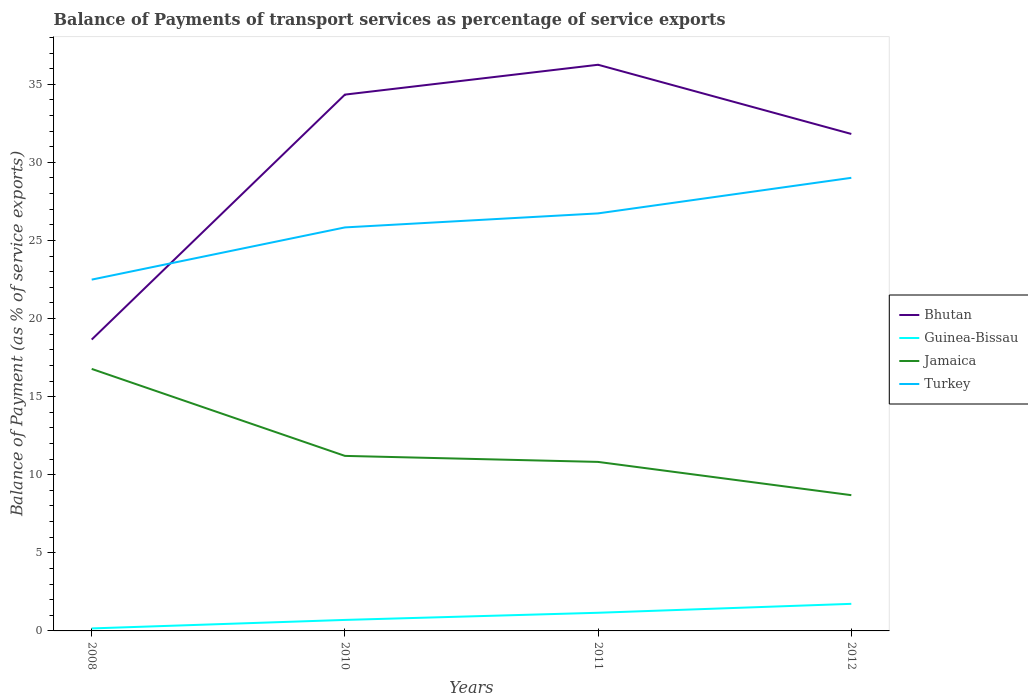Across all years, what is the maximum balance of payments of transport services in Jamaica?
Your answer should be compact. 8.69. What is the total balance of payments of transport services in Bhutan in the graph?
Your response must be concise. -15.68. What is the difference between the highest and the second highest balance of payments of transport services in Guinea-Bissau?
Keep it short and to the point. 1.57. What is the difference between the highest and the lowest balance of payments of transport services in Turkey?
Your answer should be very brief. 2. Is the balance of payments of transport services in Jamaica strictly greater than the balance of payments of transport services in Turkey over the years?
Offer a terse response. Yes. How many lines are there?
Make the answer very short. 4. Are the values on the major ticks of Y-axis written in scientific E-notation?
Offer a terse response. No. Does the graph contain any zero values?
Keep it short and to the point. No. Does the graph contain grids?
Give a very brief answer. No. What is the title of the graph?
Your answer should be compact. Balance of Payments of transport services as percentage of service exports. What is the label or title of the X-axis?
Give a very brief answer. Years. What is the label or title of the Y-axis?
Ensure brevity in your answer.  Balance of Payment (as % of service exports). What is the Balance of Payment (as % of service exports) of Bhutan in 2008?
Offer a very short reply. 18.65. What is the Balance of Payment (as % of service exports) in Guinea-Bissau in 2008?
Offer a very short reply. 0.16. What is the Balance of Payment (as % of service exports) of Jamaica in 2008?
Give a very brief answer. 16.78. What is the Balance of Payment (as % of service exports) in Turkey in 2008?
Provide a succinct answer. 22.49. What is the Balance of Payment (as % of service exports) of Bhutan in 2010?
Provide a succinct answer. 34.34. What is the Balance of Payment (as % of service exports) of Guinea-Bissau in 2010?
Keep it short and to the point. 0.7. What is the Balance of Payment (as % of service exports) of Jamaica in 2010?
Offer a terse response. 11.21. What is the Balance of Payment (as % of service exports) of Turkey in 2010?
Give a very brief answer. 25.84. What is the Balance of Payment (as % of service exports) in Bhutan in 2011?
Ensure brevity in your answer.  36.25. What is the Balance of Payment (as % of service exports) in Guinea-Bissau in 2011?
Provide a short and direct response. 1.16. What is the Balance of Payment (as % of service exports) in Jamaica in 2011?
Make the answer very short. 10.82. What is the Balance of Payment (as % of service exports) in Turkey in 2011?
Ensure brevity in your answer.  26.73. What is the Balance of Payment (as % of service exports) of Bhutan in 2012?
Offer a terse response. 31.82. What is the Balance of Payment (as % of service exports) in Guinea-Bissau in 2012?
Ensure brevity in your answer.  1.73. What is the Balance of Payment (as % of service exports) in Jamaica in 2012?
Ensure brevity in your answer.  8.69. What is the Balance of Payment (as % of service exports) in Turkey in 2012?
Your answer should be compact. 29.01. Across all years, what is the maximum Balance of Payment (as % of service exports) in Bhutan?
Give a very brief answer. 36.25. Across all years, what is the maximum Balance of Payment (as % of service exports) in Guinea-Bissau?
Offer a very short reply. 1.73. Across all years, what is the maximum Balance of Payment (as % of service exports) of Jamaica?
Offer a very short reply. 16.78. Across all years, what is the maximum Balance of Payment (as % of service exports) of Turkey?
Your answer should be very brief. 29.01. Across all years, what is the minimum Balance of Payment (as % of service exports) of Bhutan?
Your answer should be very brief. 18.65. Across all years, what is the minimum Balance of Payment (as % of service exports) of Guinea-Bissau?
Your response must be concise. 0.16. Across all years, what is the minimum Balance of Payment (as % of service exports) in Jamaica?
Offer a terse response. 8.69. Across all years, what is the minimum Balance of Payment (as % of service exports) of Turkey?
Your answer should be compact. 22.49. What is the total Balance of Payment (as % of service exports) of Bhutan in the graph?
Your answer should be very brief. 121.06. What is the total Balance of Payment (as % of service exports) in Guinea-Bissau in the graph?
Keep it short and to the point. 3.76. What is the total Balance of Payment (as % of service exports) in Jamaica in the graph?
Give a very brief answer. 47.5. What is the total Balance of Payment (as % of service exports) in Turkey in the graph?
Provide a succinct answer. 104.07. What is the difference between the Balance of Payment (as % of service exports) of Bhutan in 2008 and that in 2010?
Your answer should be compact. -15.68. What is the difference between the Balance of Payment (as % of service exports) in Guinea-Bissau in 2008 and that in 2010?
Offer a terse response. -0.54. What is the difference between the Balance of Payment (as % of service exports) in Jamaica in 2008 and that in 2010?
Provide a succinct answer. 5.57. What is the difference between the Balance of Payment (as % of service exports) of Turkey in 2008 and that in 2010?
Give a very brief answer. -3.34. What is the difference between the Balance of Payment (as % of service exports) of Bhutan in 2008 and that in 2011?
Your answer should be compact. -17.6. What is the difference between the Balance of Payment (as % of service exports) of Guinea-Bissau in 2008 and that in 2011?
Provide a succinct answer. -1. What is the difference between the Balance of Payment (as % of service exports) of Jamaica in 2008 and that in 2011?
Your answer should be very brief. 5.96. What is the difference between the Balance of Payment (as % of service exports) of Turkey in 2008 and that in 2011?
Offer a terse response. -4.24. What is the difference between the Balance of Payment (as % of service exports) in Bhutan in 2008 and that in 2012?
Your answer should be compact. -13.17. What is the difference between the Balance of Payment (as % of service exports) in Guinea-Bissau in 2008 and that in 2012?
Ensure brevity in your answer.  -1.57. What is the difference between the Balance of Payment (as % of service exports) of Jamaica in 2008 and that in 2012?
Give a very brief answer. 8.08. What is the difference between the Balance of Payment (as % of service exports) in Turkey in 2008 and that in 2012?
Keep it short and to the point. -6.52. What is the difference between the Balance of Payment (as % of service exports) of Bhutan in 2010 and that in 2011?
Keep it short and to the point. -1.91. What is the difference between the Balance of Payment (as % of service exports) of Guinea-Bissau in 2010 and that in 2011?
Offer a terse response. -0.46. What is the difference between the Balance of Payment (as % of service exports) in Jamaica in 2010 and that in 2011?
Offer a terse response. 0.39. What is the difference between the Balance of Payment (as % of service exports) in Turkey in 2010 and that in 2011?
Your response must be concise. -0.9. What is the difference between the Balance of Payment (as % of service exports) in Bhutan in 2010 and that in 2012?
Make the answer very short. 2.52. What is the difference between the Balance of Payment (as % of service exports) in Guinea-Bissau in 2010 and that in 2012?
Keep it short and to the point. -1.03. What is the difference between the Balance of Payment (as % of service exports) in Jamaica in 2010 and that in 2012?
Provide a succinct answer. 2.52. What is the difference between the Balance of Payment (as % of service exports) of Turkey in 2010 and that in 2012?
Ensure brevity in your answer.  -3.18. What is the difference between the Balance of Payment (as % of service exports) of Bhutan in 2011 and that in 2012?
Provide a short and direct response. 4.43. What is the difference between the Balance of Payment (as % of service exports) of Guinea-Bissau in 2011 and that in 2012?
Provide a short and direct response. -0.57. What is the difference between the Balance of Payment (as % of service exports) of Jamaica in 2011 and that in 2012?
Offer a very short reply. 2.13. What is the difference between the Balance of Payment (as % of service exports) in Turkey in 2011 and that in 2012?
Ensure brevity in your answer.  -2.28. What is the difference between the Balance of Payment (as % of service exports) of Bhutan in 2008 and the Balance of Payment (as % of service exports) of Guinea-Bissau in 2010?
Your answer should be compact. 17.95. What is the difference between the Balance of Payment (as % of service exports) of Bhutan in 2008 and the Balance of Payment (as % of service exports) of Jamaica in 2010?
Provide a short and direct response. 7.45. What is the difference between the Balance of Payment (as % of service exports) of Bhutan in 2008 and the Balance of Payment (as % of service exports) of Turkey in 2010?
Provide a short and direct response. -7.18. What is the difference between the Balance of Payment (as % of service exports) in Guinea-Bissau in 2008 and the Balance of Payment (as % of service exports) in Jamaica in 2010?
Give a very brief answer. -11.05. What is the difference between the Balance of Payment (as % of service exports) in Guinea-Bissau in 2008 and the Balance of Payment (as % of service exports) in Turkey in 2010?
Provide a succinct answer. -25.68. What is the difference between the Balance of Payment (as % of service exports) of Jamaica in 2008 and the Balance of Payment (as % of service exports) of Turkey in 2010?
Your response must be concise. -9.06. What is the difference between the Balance of Payment (as % of service exports) of Bhutan in 2008 and the Balance of Payment (as % of service exports) of Guinea-Bissau in 2011?
Your response must be concise. 17.49. What is the difference between the Balance of Payment (as % of service exports) of Bhutan in 2008 and the Balance of Payment (as % of service exports) of Jamaica in 2011?
Keep it short and to the point. 7.83. What is the difference between the Balance of Payment (as % of service exports) of Bhutan in 2008 and the Balance of Payment (as % of service exports) of Turkey in 2011?
Offer a terse response. -8.08. What is the difference between the Balance of Payment (as % of service exports) in Guinea-Bissau in 2008 and the Balance of Payment (as % of service exports) in Jamaica in 2011?
Your answer should be very brief. -10.66. What is the difference between the Balance of Payment (as % of service exports) of Guinea-Bissau in 2008 and the Balance of Payment (as % of service exports) of Turkey in 2011?
Make the answer very short. -26.57. What is the difference between the Balance of Payment (as % of service exports) of Jamaica in 2008 and the Balance of Payment (as % of service exports) of Turkey in 2011?
Offer a terse response. -9.96. What is the difference between the Balance of Payment (as % of service exports) of Bhutan in 2008 and the Balance of Payment (as % of service exports) of Guinea-Bissau in 2012?
Your response must be concise. 16.92. What is the difference between the Balance of Payment (as % of service exports) in Bhutan in 2008 and the Balance of Payment (as % of service exports) in Jamaica in 2012?
Your response must be concise. 9.96. What is the difference between the Balance of Payment (as % of service exports) in Bhutan in 2008 and the Balance of Payment (as % of service exports) in Turkey in 2012?
Your answer should be very brief. -10.36. What is the difference between the Balance of Payment (as % of service exports) in Guinea-Bissau in 2008 and the Balance of Payment (as % of service exports) in Jamaica in 2012?
Your answer should be compact. -8.53. What is the difference between the Balance of Payment (as % of service exports) of Guinea-Bissau in 2008 and the Balance of Payment (as % of service exports) of Turkey in 2012?
Offer a terse response. -28.85. What is the difference between the Balance of Payment (as % of service exports) in Jamaica in 2008 and the Balance of Payment (as % of service exports) in Turkey in 2012?
Give a very brief answer. -12.23. What is the difference between the Balance of Payment (as % of service exports) of Bhutan in 2010 and the Balance of Payment (as % of service exports) of Guinea-Bissau in 2011?
Provide a succinct answer. 33.18. What is the difference between the Balance of Payment (as % of service exports) in Bhutan in 2010 and the Balance of Payment (as % of service exports) in Jamaica in 2011?
Make the answer very short. 23.52. What is the difference between the Balance of Payment (as % of service exports) of Bhutan in 2010 and the Balance of Payment (as % of service exports) of Turkey in 2011?
Offer a very short reply. 7.6. What is the difference between the Balance of Payment (as % of service exports) in Guinea-Bissau in 2010 and the Balance of Payment (as % of service exports) in Jamaica in 2011?
Provide a short and direct response. -10.12. What is the difference between the Balance of Payment (as % of service exports) in Guinea-Bissau in 2010 and the Balance of Payment (as % of service exports) in Turkey in 2011?
Keep it short and to the point. -26.03. What is the difference between the Balance of Payment (as % of service exports) in Jamaica in 2010 and the Balance of Payment (as % of service exports) in Turkey in 2011?
Your answer should be very brief. -15.53. What is the difference between the Balance of Payment (as % of service exports) of Bhutan in 2010 and the Balance of Payment (as % of service exports) of Guinea-Bissau in 2012?
Offer a terse response. 32.6. What is the difference between the Balance of Payment (as % of service exports) of Bhutan in 2010 and the Balance of Payment (as % of service exports) of Jamaica in 2012?
Your answer should be compact. 25.65. What is the difference between the Balance of Payment (as % of service exports) in Bhutan in 2010 and the Balance of Payment (as % of service exports) in Turkey in 2012?
Your answer should be compact. 5.33. What is the difference between the Balance of Payment (as % of service exports) of Guinea-Bissau in 2010 and the Balance of Payment (as % of service exports) of Jamaica in 2012?
Offer a terse response. -7.99. What is the difference between the Balance of Payment (as % of service exports) in Guinea-Bissau in 2010 and the Balance of Payment (as % of service exports) in Turkey in 2012?
Make the answer very short. -28.31. What is the difference between the Balance of Payment (as % of service exports) of Jamaica in 2010 and the Balance of Payment (as % of service exports) of Turkey in 2012?
Keep it short and to the point. -17.8. What is the difference between the Balance of Payment (as % of service exports) in Bhutan in 2011 and the Balance of Payment (as % of service exports) in Guinea-Bissau in 2012?
Make the answer very short. 34.52. What is the difference between the Balance of Payment (as % of service exports) in Bhutan in 2011 and the Balance of Payment (as % of service exports) in Jamaica in 2012?
Keep it short and to the point. 27.56. What is the difference between the Balance of Payment (as % of service exports) of Bhutan in 2011 and the Balance of Payment (as % of service exports) of Turkey in 2012?
Ensure brevity in your answer.  7.24. What is the difference between the Balance of Payment (as % of service exports) of Guinea-Bissau in 2011 and the Balance of Payment (as % of service exports) of Jamaica in 2012?
Provide a short and direct response. -7.53. What is the difference between the Balance of Payment (as % of service exports) of Guinea-Bissau in 2011 and the Balance of Payment (as % of service exports) of Turkey in 2012?
Provide a short and direct response. -27.85. What is the difference between the Balance of Payment (as % of service exports) in Jamaica in 2011 and the Balance of Payment (as % of service exports) in Turkey in 2012?
Offer a very short reply. -18.19. What is the average Balance of Payment (as % of service exports) in Bhutan per year?
Your response must be concise. 30.27. What is the average Balance of Payment (as % of service exports) in Guinea-Bissau per year?
Your answer should be compact. 0.94. What is the average Balance of Payment (as % of service exports) of Jamaica per year?
Your answer should be compact. 11.87. What is the average Balance of Payment (as % of service exports) of Turkey per year?
Ensure brevity in your answer.  26.02. In the year 2008, what is the difference between the Balance of Payment (as % of service exports) in Bhutan and Balance of Payment (as % of service exports) in Guinea-Bissau?
Your response must be concise. 18.49. In the year 2008, what is the difference between the Balance of Payment (as % of service exports) of Bhutan and Balance of Payment (as % of service exports) of Jamaica?
Your answer should be compact. 1.88. In the year 2008, what is the difference between the Balance of Payment (as % of service exports) of Bhutan and Balance of Payment (as % of service exports) of Turkey?
Your response must be concise. -3.84. In the year 2008, what is the difference between the Balance of Payment (as % of service exports) in Guinea-Bissau and Balance of Payment (as % of service exports) in Jamaica?
Provide a succinct answer. -16.62. In the year 2008, what is the difference between the Balance of Payment (as % of service exports) in Guinea-Bissau and Balance of Payment (as % of service exports) in Turkey?
Offer a very short reply. -22.33. In the year 2008, what is the difference between the Balance of Payment (as % of service exports) in Jamaica and Balance of Payment (as % of service exports) in Turkey?
Offer a terse response. -5.72. In the year 2010, what is the difference between the Balance of Payment (as % of service exports) of Bhutan and Balance of Payment (as % of service exports) of Guinea-Bissau?
Make the answer very short. 33.63. In the year 2010, what is the difference between the Balance of Payment (as % of service exports) of Bhutan and Balance of Payment (as % of service exports) of Jamaica?
Provide a succinct answer. 23.13. In the year 2010, what is the difference between the Balance of Payment (as % of service exports) in Bhutan and Balance of Payment (as % of service exports) in Turkey?
Provide a short and direct response. 8.5. In the year 2010, what is the difference between the Balance of Payment (as % of service exports) of Guinea-Bissau and Balance of Payment (as % of service exports) of Jamaica?
Your answer should be very brief. -10.5. In the year 2010, what is the difference between the Balance of Payment (as % of service exports) in Guinea-Bissau and Balance of Payment (as % of service exports) in Turkey?
Provide a succinct answer. -25.13. In the year 2010, what is the difference between the Balance of Payment (as % of service exports) of Jamaica and Balance of Payment (as % of service exports) of Turkey?
Your answer should be compact. -14.63. In the year 2011, what is the difference between the Balance of Payment (as % of service exports) in Bhutan and Balance of Payment (as % of service exports) in Guinea-Bissau?
Provide a succinct answer. 35.09. In the year 2011, what is the difference between the Balance of Payment (as % of service exports) in Bhutan and Balance of Payment (as % of service exports) in Jamaica?
Offer a very short reply. 25.43. In the year 2011, what is the difference between the Balance of Payment (as % of service exports) of Bhutan and Balance of Payment (as % of service exports) of Turkey?
Your answer should be very brief. 9.52. In the year 2011, what is the difference between the Balance of Payment (as % of service exports) of Guinea-Bissau and Balance of Payment (as % of service exports) of Jamaica?
Offer a terse response. -9.66. In the year 2011, what is the difference between the Balance of Payment (as % of service exports) in Guinea-Bissau and Balance of Payment (as % of service exports) in Turkey?
Ensure brevity in your answer.  -25.57. In the year 2011, what is the difference between the Balance of Payment (as % of service exports) of Jamaica and Balance of Payment (as % of service exports) of Turkey?
Offer a terse response. -15.91. In the year 2012, what is the difference between the Balance of Payment (as % of service exports) in Bhutan and Balance of Payment (as % of service exports) in Guinea-Bissau?
Your answer should be very brief. 30.09. In the year 2012, what is the difference between the Balance of Payment (as % of service exports) of Bhutan and Balance of Payment (as % of service exports) of Jamaica?
Your response must be concise. 23.13. In the year 2012, what is the difference between the Balance of Payment (as % of service exports) of Bhutan and Balance of Payment (as % of service exports) of Turkey?
Provide a succinct answer. 2.81. In the year 2012, what is the difference between the Balance of Payment (as % of service exports) in Guinea-Bissau and Balance of Payment (as % of service exports) in Jamaica?
Give a very brief answer. -6.96. In the year 2012, what is the difference between the Balance of Payment (as % of service exports) of Guinea-Bissau and Balance of Payment (as % of service exports) of Turkey?
Provide a succinct answer. -27.28. In the year 2012, what is the difference between the Balance of Payment (as % of service exports) of Jamaica and Balance of Payment (as % of service exports) of Turkey?
Give a very brief answer. -20.32. What is the ratio of the Balance of Payment (as % of service exports) of Bhutan in 2008 to that in 2010?
Provide a short and direct response. 0.54. What is the ratio of the Balance of Payment (as % of service exports) of Guinea-Bissau in 2008 to that in 2010?
Provide a short and direct response. 0.23. What is the ratio of the Balance of Payment (as % of service exports) of Jamaica in 2008 to that in 2010?
Give a very brief answer. 1.5. What is the ratio of the Balance of Payment (as % of service exports) of Turkey in 2008 to that in 2010?
Ensure brevity in your answer.  0.87. What is the ratio of the Balance of Payment (as % of service exports) in Bhutan in 2008 to that in 2011?
Your response must be concise. 0.51. What is the ratio of the Balance of Payment (as % of service exports) of Guinea-Bissau in 2008 to that in 2011?
Your answer should be compact. 0.14. What is the ratio of the Balance of Payment (as % of service exports) of Jamaica in 2008 to that in 2011?
Make the answer very short. 1.55. What is the ratio of the Balance of Payment (as % of service exports) of Turkey in 2008 to that in 2011?
Offer a very short reply. 0.84. What is the ratio of the Balance of Payment (as % of service exports) in Bhutan in 2008 to that in 2012?
Your answer should be compact. 0.59. What is the ratio of the Balance of Payment (as % of service exports) of Guinea-Bissau in 2008 to that in 2012?
Offer a very short reply. 0.09. What is the ratio of the Balance of Payment (as % of service exports) of Jamaica in 2008 to that in 2012?
Ensure brevity in your answer.  1.93. What is the ratio of the Balance of Payment (as % of service exports) of Turkey in 2008 to that in 2012?
Offer a terse response. 0.78. What is the ratio of the Balance of Payment (as % of service exports) in Bhutan in 2010 to that in 2011?
Give a very brief answer. 0.95. What is the ratio of the Balance of Payment (as % of service exports) of Guinea-Bissau in 2010 to that in 2011?
Provide a succinct answer. 0.61. What is the ratio of the Balance of Payment (as % of service exports) in Jamaica in 2010 to that in 2011?
Your answer should be very brief. 1.04. What is the ratio of the Balance of Payment (as % of service exports) in Turkey in 2010 to that in 2011?
Your answer should be compact. 0.97. What is the ratio of the Balance of Payment (as % of service exports) of Bhutan in 2010 to that in 2012?
Ensure brevity in your answer.  1.08. What is the ratio of the Balance of Payment (as % of service exports) in Guinea-Bissau in 2010 to that in 2012?
Make the answer very short. 0.41. What is the ratio of the Balance of Payment (as % of service exports) in Jamaica in 2010 to that in 2012?
Give a very brief answer. 1.29. What is the ratio of the Balance of Payment (as % of service exports) of Turkey in 2010 to that in 2012?
Your answer should be very brief. 0.89. What is the ratio of the Balance of Payment (as % of service exports) of Bhutan in 2011 to that in 2012?
Ensure brevity in your answer.  1.14. What is the ratio of the Balance of Payment (as % of service exports) of Guinea-Bissau in 2011 to that in 2012?
Offer a terse response. 0.67. What is the ratio of the Balance of Payment (as % of service exports) of Jamaica in 2011 to that in 2012?
Ensure brevity in your answer.  1.25. What is the ratio of the Balance of Payment (as % of service exports) of Turkey in 2011 to that in 2012?
Provide a short and direct response. 0.92. What is the difference between the highest and the second highest Balance of Payment (as % of service exports) of Bhutan?
Your response must be concise. 1.91. What is the difference between the highest and the second highest Balance of Payment (as % of service exports) in Jamaica?
Your answer should be compact. 5.57. What is the difference between the highest and the second highest Balance of Payment (as % of service exports) in Turkey?
Ensure brevity in your answer.  2.28. What is the difference between the highest and the lowest Balance of Payment (as % of service exports) of Bhutan?
Ensure brevity in your answer.  17.6. What is the difference between the highest and the lowest Balance of Payment (as % of service exports) in Guinea-Bissau?
Give a very brief answer. 1.57. What is the difference between the highest and the lowest Balance of Payment (as % of service exports) of Jamaica?
Provide a short and direct response. 8.08. What is the difference between the highest and the lowest Balance of Payment (as % of service exports) in Turkey?
Offer a very short reply. 6.52. 